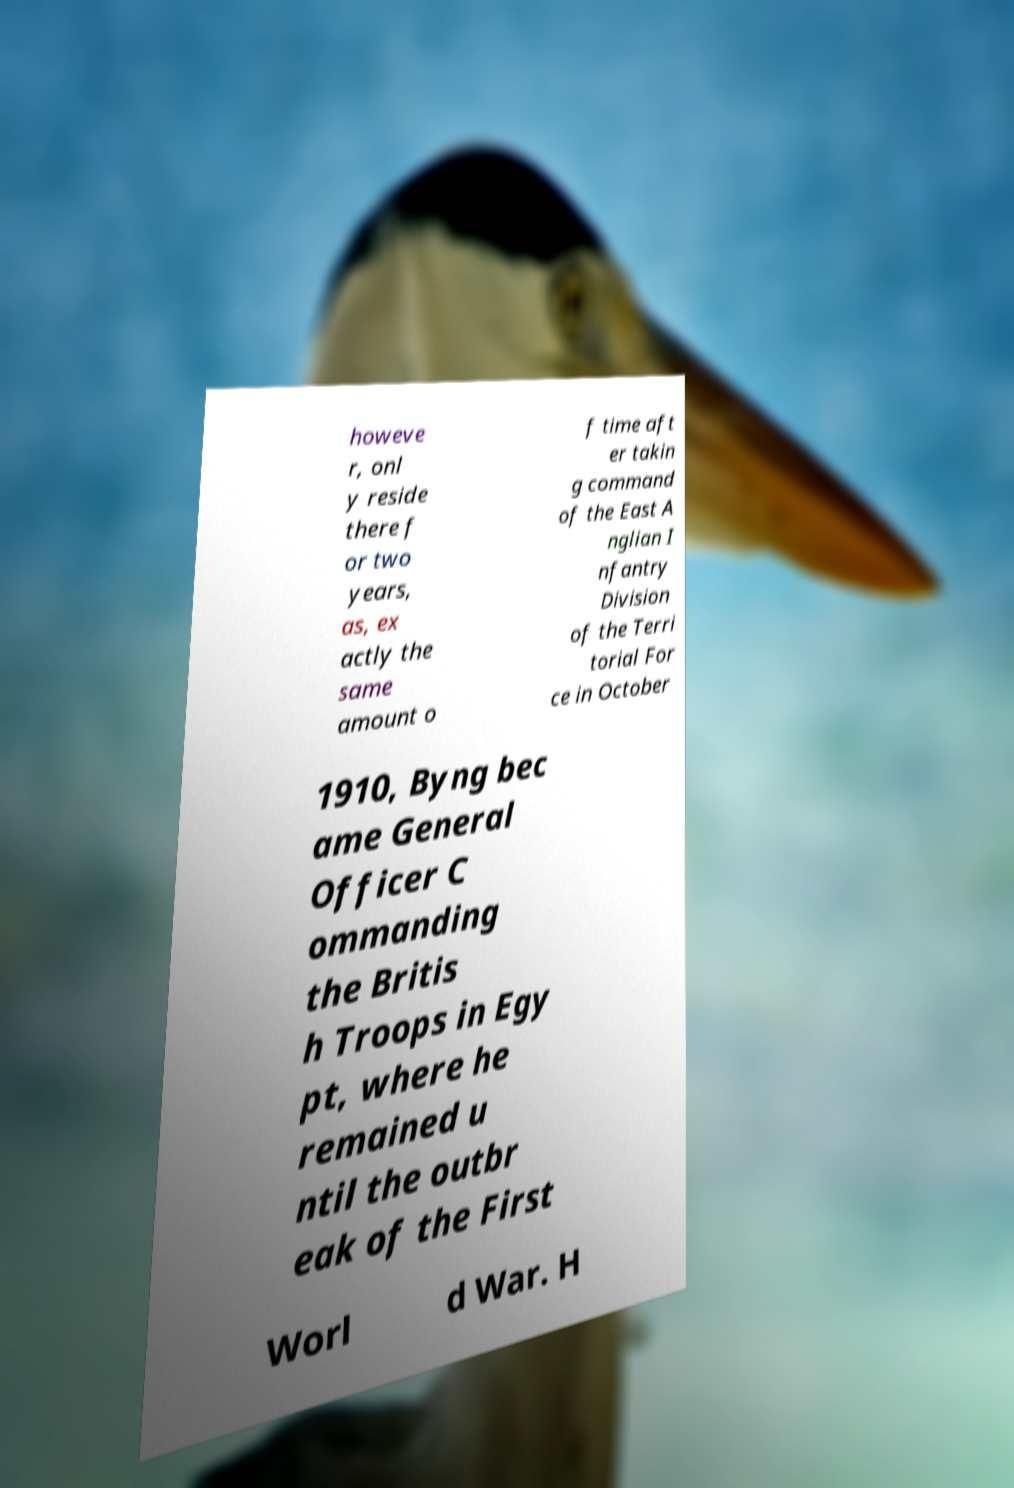There's text embedded in this image that I need extracted. Can you transcribe it verbatim? howeve r, onl y reside there f or two years, as, ex actly the same amount o f time aft er takin g command of the East A nglian I nfantry Division of the Terri torial For ce in October 1910, Byng bec ame General Officer C ommanding the Britis h Troops in Egy pt, where he remained u ntil the outbr eak of the First Worl d War. H 